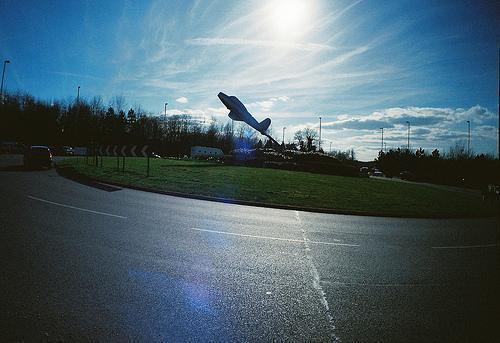How many planes are in the photo?
Give a very brief answer. 1. How many street lamps are there?
Give a very brief answer. 8. 